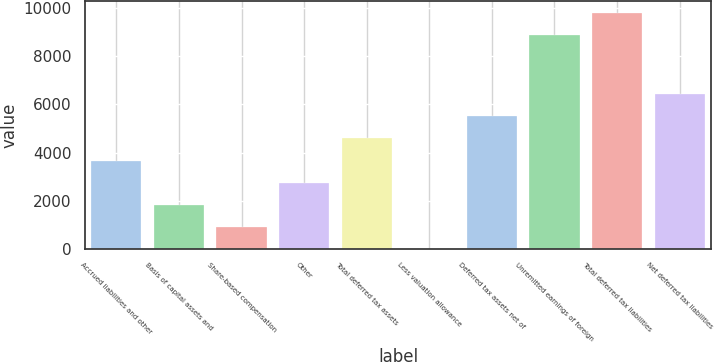Convert chart. <chart><loc_0><loc_0><loc_500><loc_500><bar_chart><fcel>Accrued liabilities and other<fcel>Basis of capital assets and<fcel>Share-based compensation<fcel>Other<fcel>Total deferred tax assets<fcel>Less valuation allowance<fcel>Deferred tax assets net of<fcel>Unremitted earnings of foreign<fcel>Total deferred tax liabilities<fcel>Net deferred tax liabilities<nl><fcel>3669.81<fcel>1837.09<fcel>920.72<fcel>2753.45<fcel>4586.18<fcel>4.35<fcel>5502.55<fcel>8896<fcel>9812.36<fcel>6418.91<nl></chart> 